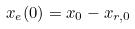Convert formula to latex. <formula><loc_0><loc_0><loc_500><loc_500>x _ { e } ( 0 ) = x _ { 0 } - x _ { r , 0 }</formula> 